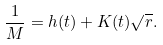<formula> <loc_0><loc_0><loc_500><loc_500>\frac { 1 } { M } = h ( t ) + K ( t ) \sqrt { r } .</formula> 